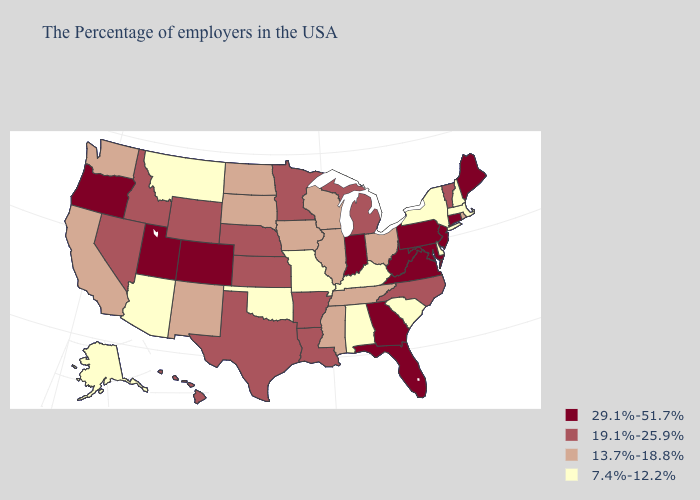Among the states that border New Hampshire , does Massachusetts have the lowest value?
Quick response, please. Yes. Which states have the lowest value in the USA?
Give a very brief answer. Massachusetts, New Hampshire, New York, Delaware, South Carolina, Kentucky, Alabama, Missouri, Oklahoma, Montana, Arizona, Alaska. What is the highest value in the South ?
Keep it brief. 29.1%-51.7%. What is the lowest value in the Northeast?
Short answer required. 7.4%-12.2%. What is the value of Illinois?
Concise answer only. 13.7%-18.8%. Name the states that have a value in the range 7.4%-12.2%?
Be succinct. Massachusetts, New Hampshire, New York, Delaware, South Carolina, Kentucky, Alabama, Missouri, Oklahoma, Montana, Arizona, Alaska. Name the states that have a value in the range 7.4%-12.2%?
Be succinct. Massachusetts, New Hampshire, New York, Delaware, South Carolina, Kentucky, Alabama, Missouri, Oklahoma, Montana, Arizona, Alaska. What is the value of Alaska?
Write a very short answer. 7.4%-12.2%. What is the value of Hawaii?
Answer briefly. 19.1%-25.9%. Does Washington have the highest value in the West?
Quick response, please. No. Does Louisiana have the same value as Vermont?
Quick response, please. Yes. Which states have the lowest value in the USA?
Concise answer only. Massachusetts, New Hampshire, New York, Delaware, South Carolina, Kentucky, Alabama, Missouri, Oklahoma, Montana, Arizona, Alaska. Does the first symbol in the legend represent the smallest category?
Short answer required. No. What is the value of Illinois?
Concise answer only. 13.7%-18.8%. What is the value of Mississippi?
Answer briefly. 13.7%-18.8%. 